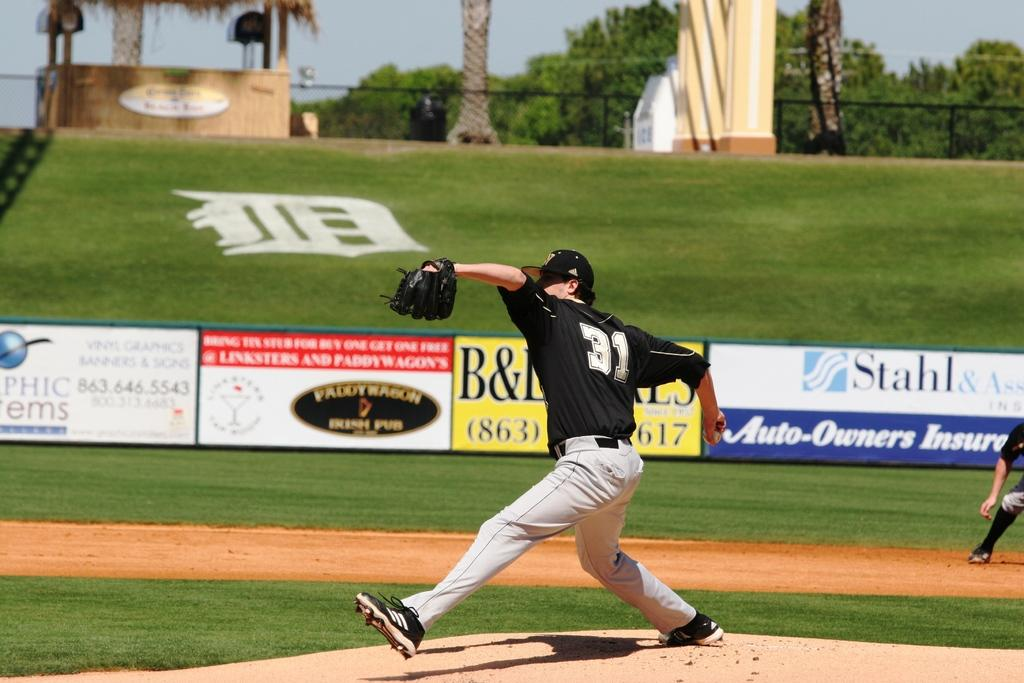Provide a one-sentence caption for the provided image. The pitcher wears number 31 and is about to release the baseball. 